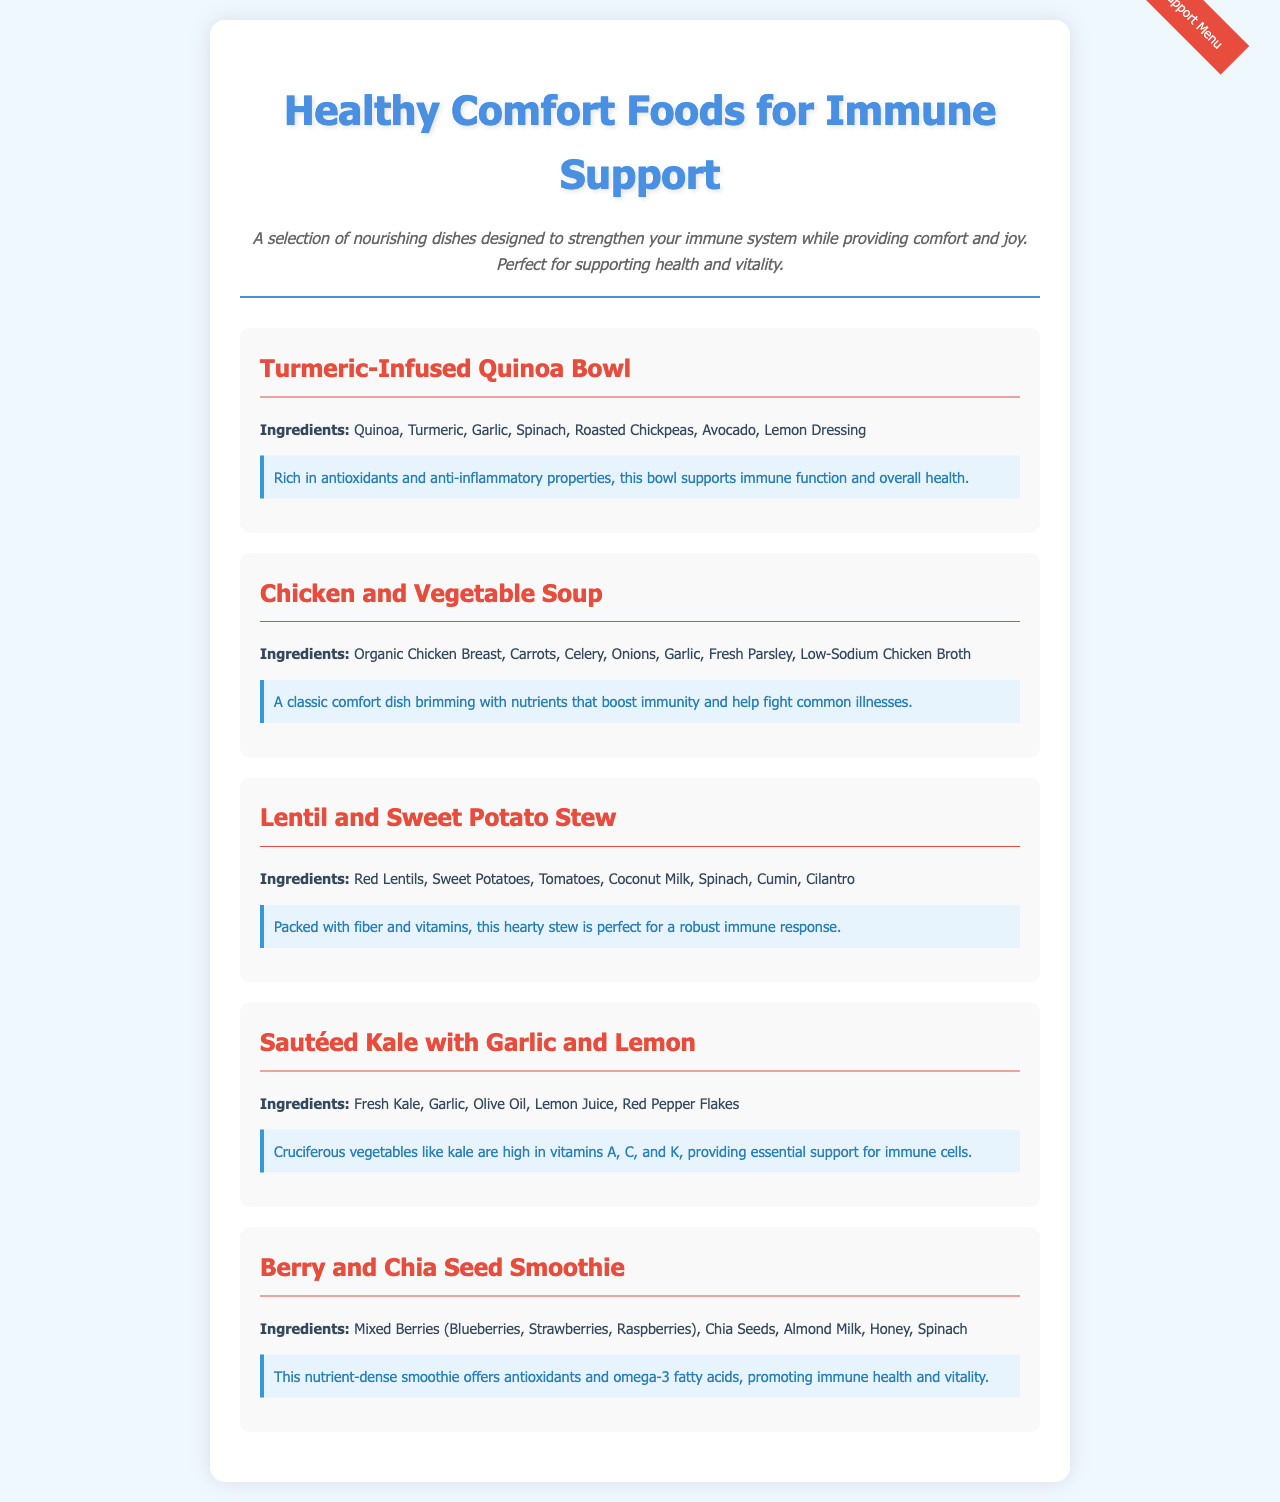What is the name of the first menu item? The first menu item listed in the menu is the Turmeric-Infused Quinoa Bowl.
Answer: Turmeric-Infused Quinoa Bowl What key ingredient is included in the Berry and Chia Seed Smoothie? The Berry and Chia Seed Smoothie includes mixed berries as a key ingredient.
Answer: Mixed Berries How many ingredients are listed for the Chicken and Vegetable Soup? The Chicken and Vegetable Soup has seven ingredients listed in the document.
Answer: Seven Which menu item is rich in antioxidants and anti-inflammatory properties? The Turmeric-Infused Quinoa Bowl is the item known for its rich antioxidants and anti-inflammatory properties.
Answer: Turmeric-Infused Quinoa Bowl What vegetable is highlighted in the Sautéed Kale with Garlic and Lemon? The highlighted vegetable in the Sautéed Kale with Garlic and Lemon is kale.
Answer: Kale Which dish is described as a "classic comfort dish"? The Chicken and Vegetable Soup is described as a "classic comfort dish".
Answer: Chicken and Vegetable Soup What type of milk is used in the Berry and Chia Seed Smoothie? Almond milk is the type of milk used in the Berry and Chia Seed Smoothie.
Answer: Almond Milk What health benefit is associated with the Lentil and Sweet Potato Stew? The Lentil and Sweet Potato Stew is associated with a robust immune response due to its high fiber and vitamin content.
Answer: Robust immune response What is a common ingredient in all the dishes listed? Garlic is a common ingredient found in multiple dishes on the menu.
Answer: Garlic 